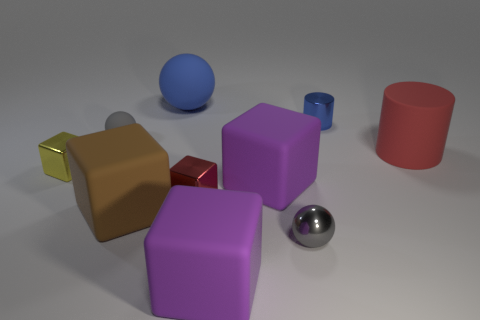What number of other objects are there of the same shape as the yellow metallic object?
Your answer should be very brief. 4. Are there more yellow shiny things that are on the left side of the red cylinder than red metal cylinders?
Make the answer very short. Yes. What is the size of the blue thing that is the same shape as the gray shiny thing?
Your response must be concise. Large. The gray rubber thing has what shape?
Keep it short and to the point. Sphere. There is a yellow thing that is the same size as the blue shiny thing; what shape is it?
Give a very brief answer. Cube. Are there any other things of the same color as the large cylinder?
Offer a very short reply. Yes. There is a brown cube that is made of the same material as the big blue object; what size is it?
Give a very brief answer. Large. Does the brown rubber object have the same shape as the gray object that is left of the big blue matte object?
Ensure brevity in your answer.  No. What size is the red rubber cylinder?
Offer a terse response. Large. Is the number of big things in front of the metal cylinder less than the number of big brown metallic balls?
Offer a terse response. No. 